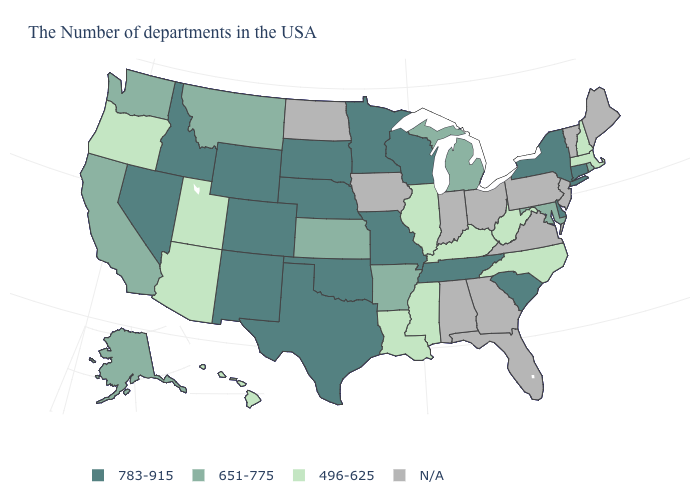Name the states that have a value in the range 496-625?
Give a very brief answer. Massachusetts, New Hampshire, North Carolina, West Virginia, Kentucky, Illinois, Mississippi, Louisiana, Utah, Arizona, Oregon, Hawaii. What is the value of California?
Give a very brief answer. 651-775. Name the states that have a value in the range 496-625?
Answer briefly. Massachusetts, New Hampshire, North Carolina, West Virginia, Kentucky, Illinois, Mississippi, Louisiana, Utah, Arizona, Oregon, Hawaii. Which states have the highest value in the USA?
Answer briefly. Connecticut, New York, Delaware, South Carolina, Tennessee, Wisconsin, Missouri, Minnesota, Nebraska, Oklahoma, Texas, South Dakota, Wyoming, Colorado, New Mexico, Idaho, Nevada. Does the map have missing data?
Be succinct. Yes. Which states hav the highest value in the MidWest?
Concise answer only. Wisconsin, Missouri, Minnesota, Nebraska, South Dakota. What is the lowest value in the USA?
Keep it brief. 496-625. Which states have the lowest value in the USA?
Be succinct. Massachusetts, New Hampshire, North Carolina, West Virginia, Kentucky, Illinois, Mississippi, Louisiana, Utah, Arizona, Oregon, Hawaii. What is the value of Kentucky?
Concise answer only. 496-625. Does Mississippi have the highest value in the South?
Quick response, please. No. 